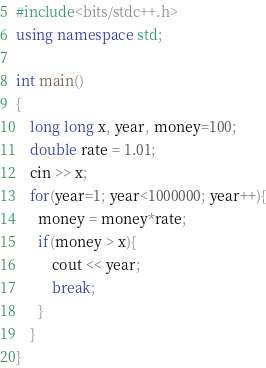<code> <loc_0><loc_0><loc_500><loc_500><_C++_>#include<bits/stdc++.h>
using namespace std;

int main()
{
    long long x, year, money=100;
    double rate = 1.01;
    cin >> x;
    for(year=1; year<1000000; year++){
      money = money*rate;
      if(money > x){
          cout << year;
          break;
      }
    }
}</code> 